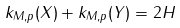<formula> <loc_0><loc_0><loc_500><loc_500>k _ { M , p } ( X ) + k _ { M , p } ( Y ) = 2 H</formula> 